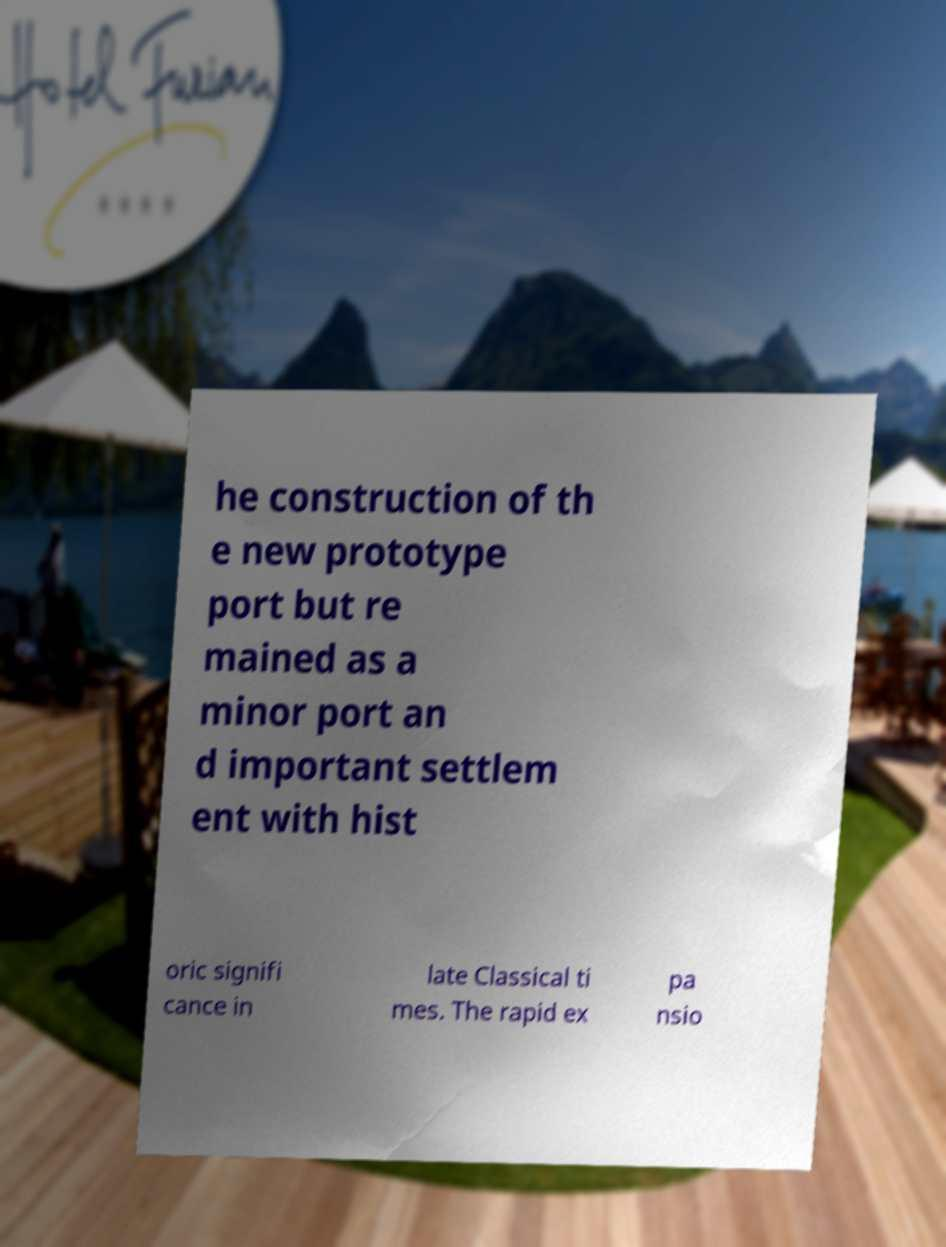Could you assist in decoding the text presented in this image and type it out clearly? he construction of th e new prototype port but re mained as a minor port an d important settlem ent with hist oric signifi cance in late Classical ti mes. The rapid ex pa nsio 